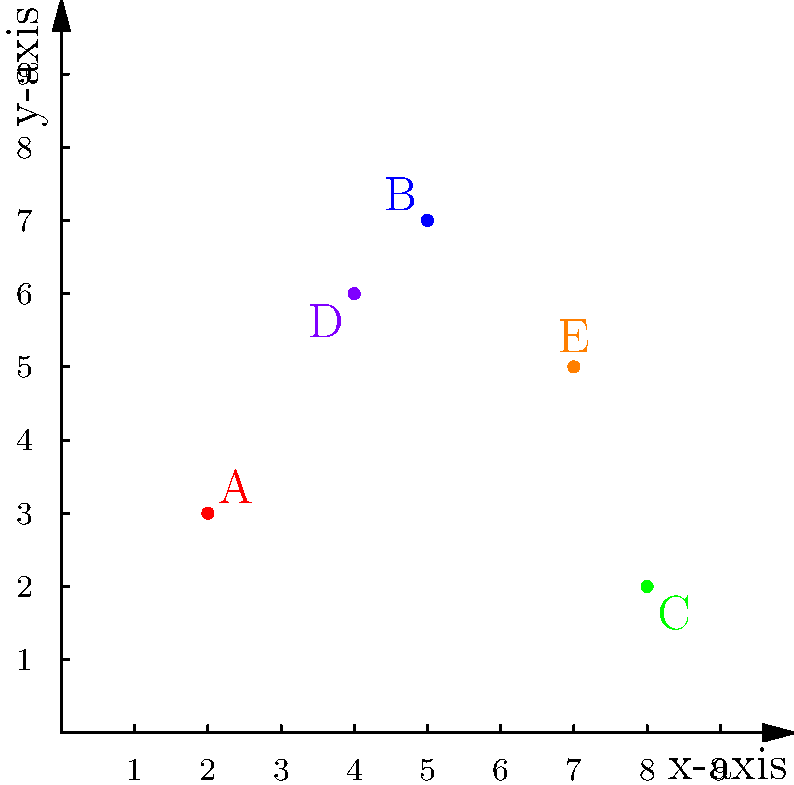As the IT director who has implemented network visualization tools, you're tasked with analyzing a network topology. The graph represents network nodes in a 2D coordinate system. Node A is at (2,3), B at (5,7), C at (8,2), D at (4,6), and E at (7,5). Which node has the shortest Euclidean distance to node E? To find the node with the shortest Euclidean distance to node E, we need to:

1. Identify the coordinates of node E: (7,5)
2. Calculate the Euclidean distance between E and each other node using the formula:
   $d = \sqrt{(x_2-x_1)^2 + (y_2-y_1)^2}$
3. Compare the distances to find the shortest one

Let's calculate:

For node A (2,3):
$d_{AE} = \sqrt{(7-2)^2 + (5-3)^2} = \sqrt{25 + 4} = \sqrt{29} \approx 5.39$

For node B (5,7):
$d_{BE} = \sqrt{(7-5)^2 + (5-7)^2} = \sqrt{4 + 4} = \sqrt{8} \approx 2.83$

For node C (8,2):
$d_{CE} = \sqrt{(7-8)^2 + (5-2)^2} = \sqrt{1 + 9} = \sqrt{10} \approx 3.16$

For node D (4,6):
$d_{DE} = \sqrt{(7-4)^2 + (5-6)^2} = \sqrt{9 + 1} = \sqrt{10} \approx 3.16$

The shortest distance is approximately 2.83, corresponding to node B.
Answer: Node B 